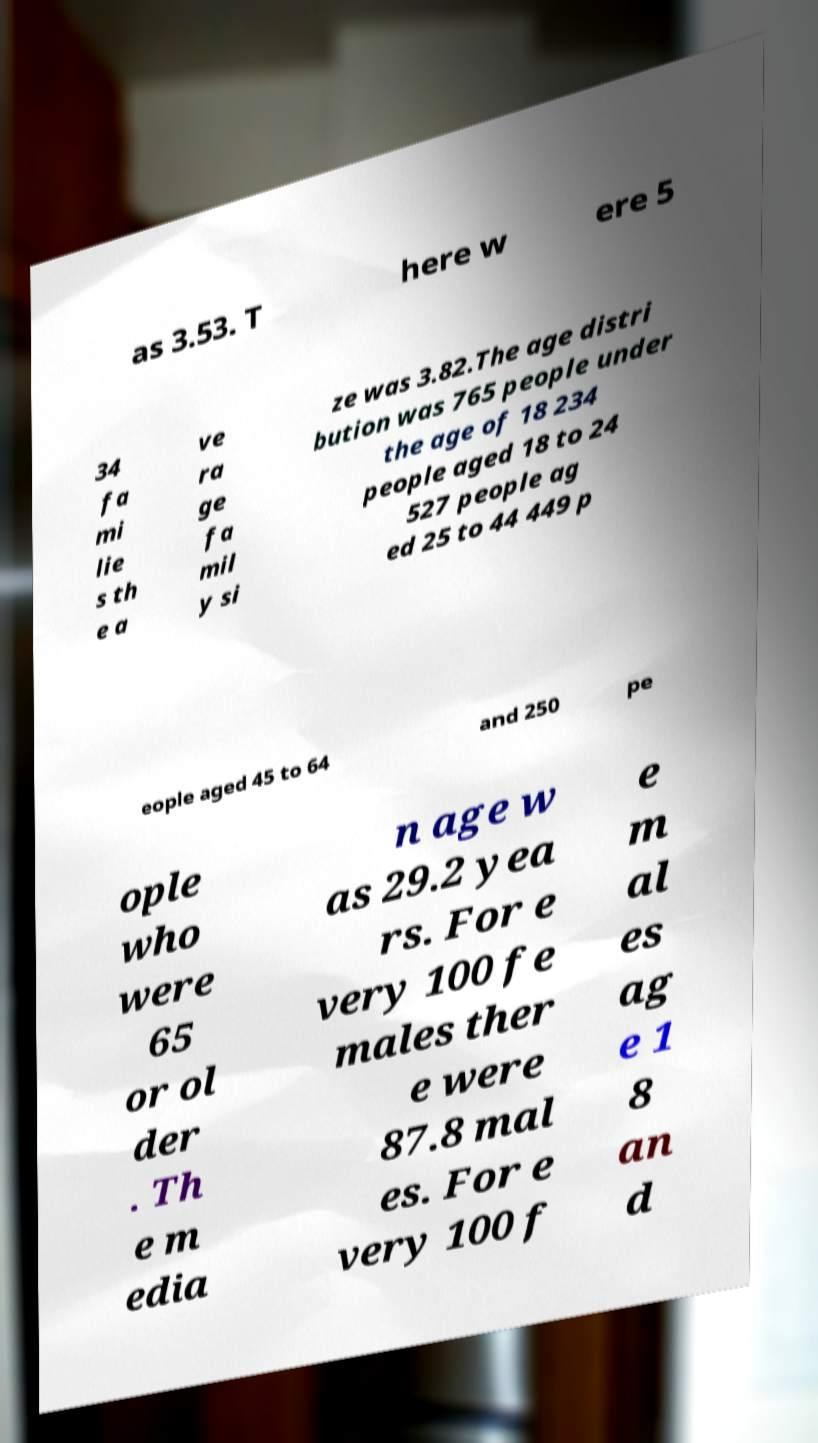Can you read and provide the text displayed in the image?This photo seems to have some interesting text. Can you extract and type it out for me? as 3.53. T here w ere 5 34 fa mi lie s th e a ve ra ge fa mil y si ze was 3.82.The age distri bution was 765 people under the age of 18 234 people aged 18 to 24 527 people ag ed 25 to 44 449 p eople aged 45 to 64 and 250 pe ople who were 65 or ol der . Th e m edia n age w as 29.2 yea rs. For e very 100 fe males ther e were 87.8 mal es. For e very 100 f e m al es ag e 1 8 an d 